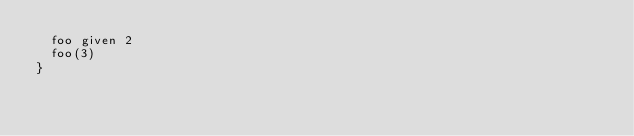Convert code to text. <code><loc_0><loc_0><loc_500><loc_500><_Scala_>  foo given 2
  foo(3)
}
</code> 